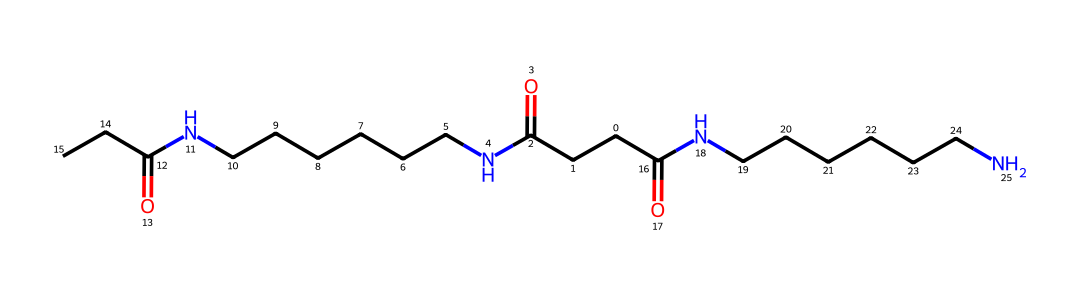What is the primary functional group present in the nylon structure? The structure contains amide linkages (–CONH–), indicated by the presence of nitrogen and carbonyl (C=O) groups bonded to it. This is a characteristic feature of nylon polymers.
Answer: amide How many nitrogen atoms are present in the chemical structure? By examining the SMILES representation, we can count two distinct nitrogen atoms present in the amide groups.
Answer: two What type of polymer is represented by this structure? This chemical structure exemplifies a polyamide, which is categorized as nylon, due to the presence of repeating amide linkages in the backbone.
Answer: polyamide What is the molecular formula represented by the SMILES? By analyzing the atoms in the SMILES notation, we ascertain that the molecular formula is C16H30N4O2, which provides the composition of the nylon fiber.
Answer: C16H30N4O2 What property does the long carbon chain suggest about the fiber's texture? The extended carbon chain (indicated by the numerous carbon atoms in the structure) suggests that the fiber is likely to be strong and durable, which is a typical property of nylon fibers used in textiles like hospital gowns.
Answer: strong and durable How many carbon atoms can be found in the nylon molecule? The structure indicates a total of sixteen carbon atoms based on the analyzed SMILES string, which defines the length of the hydrocarbon chain in the polyamide.
Answer: sixteen 